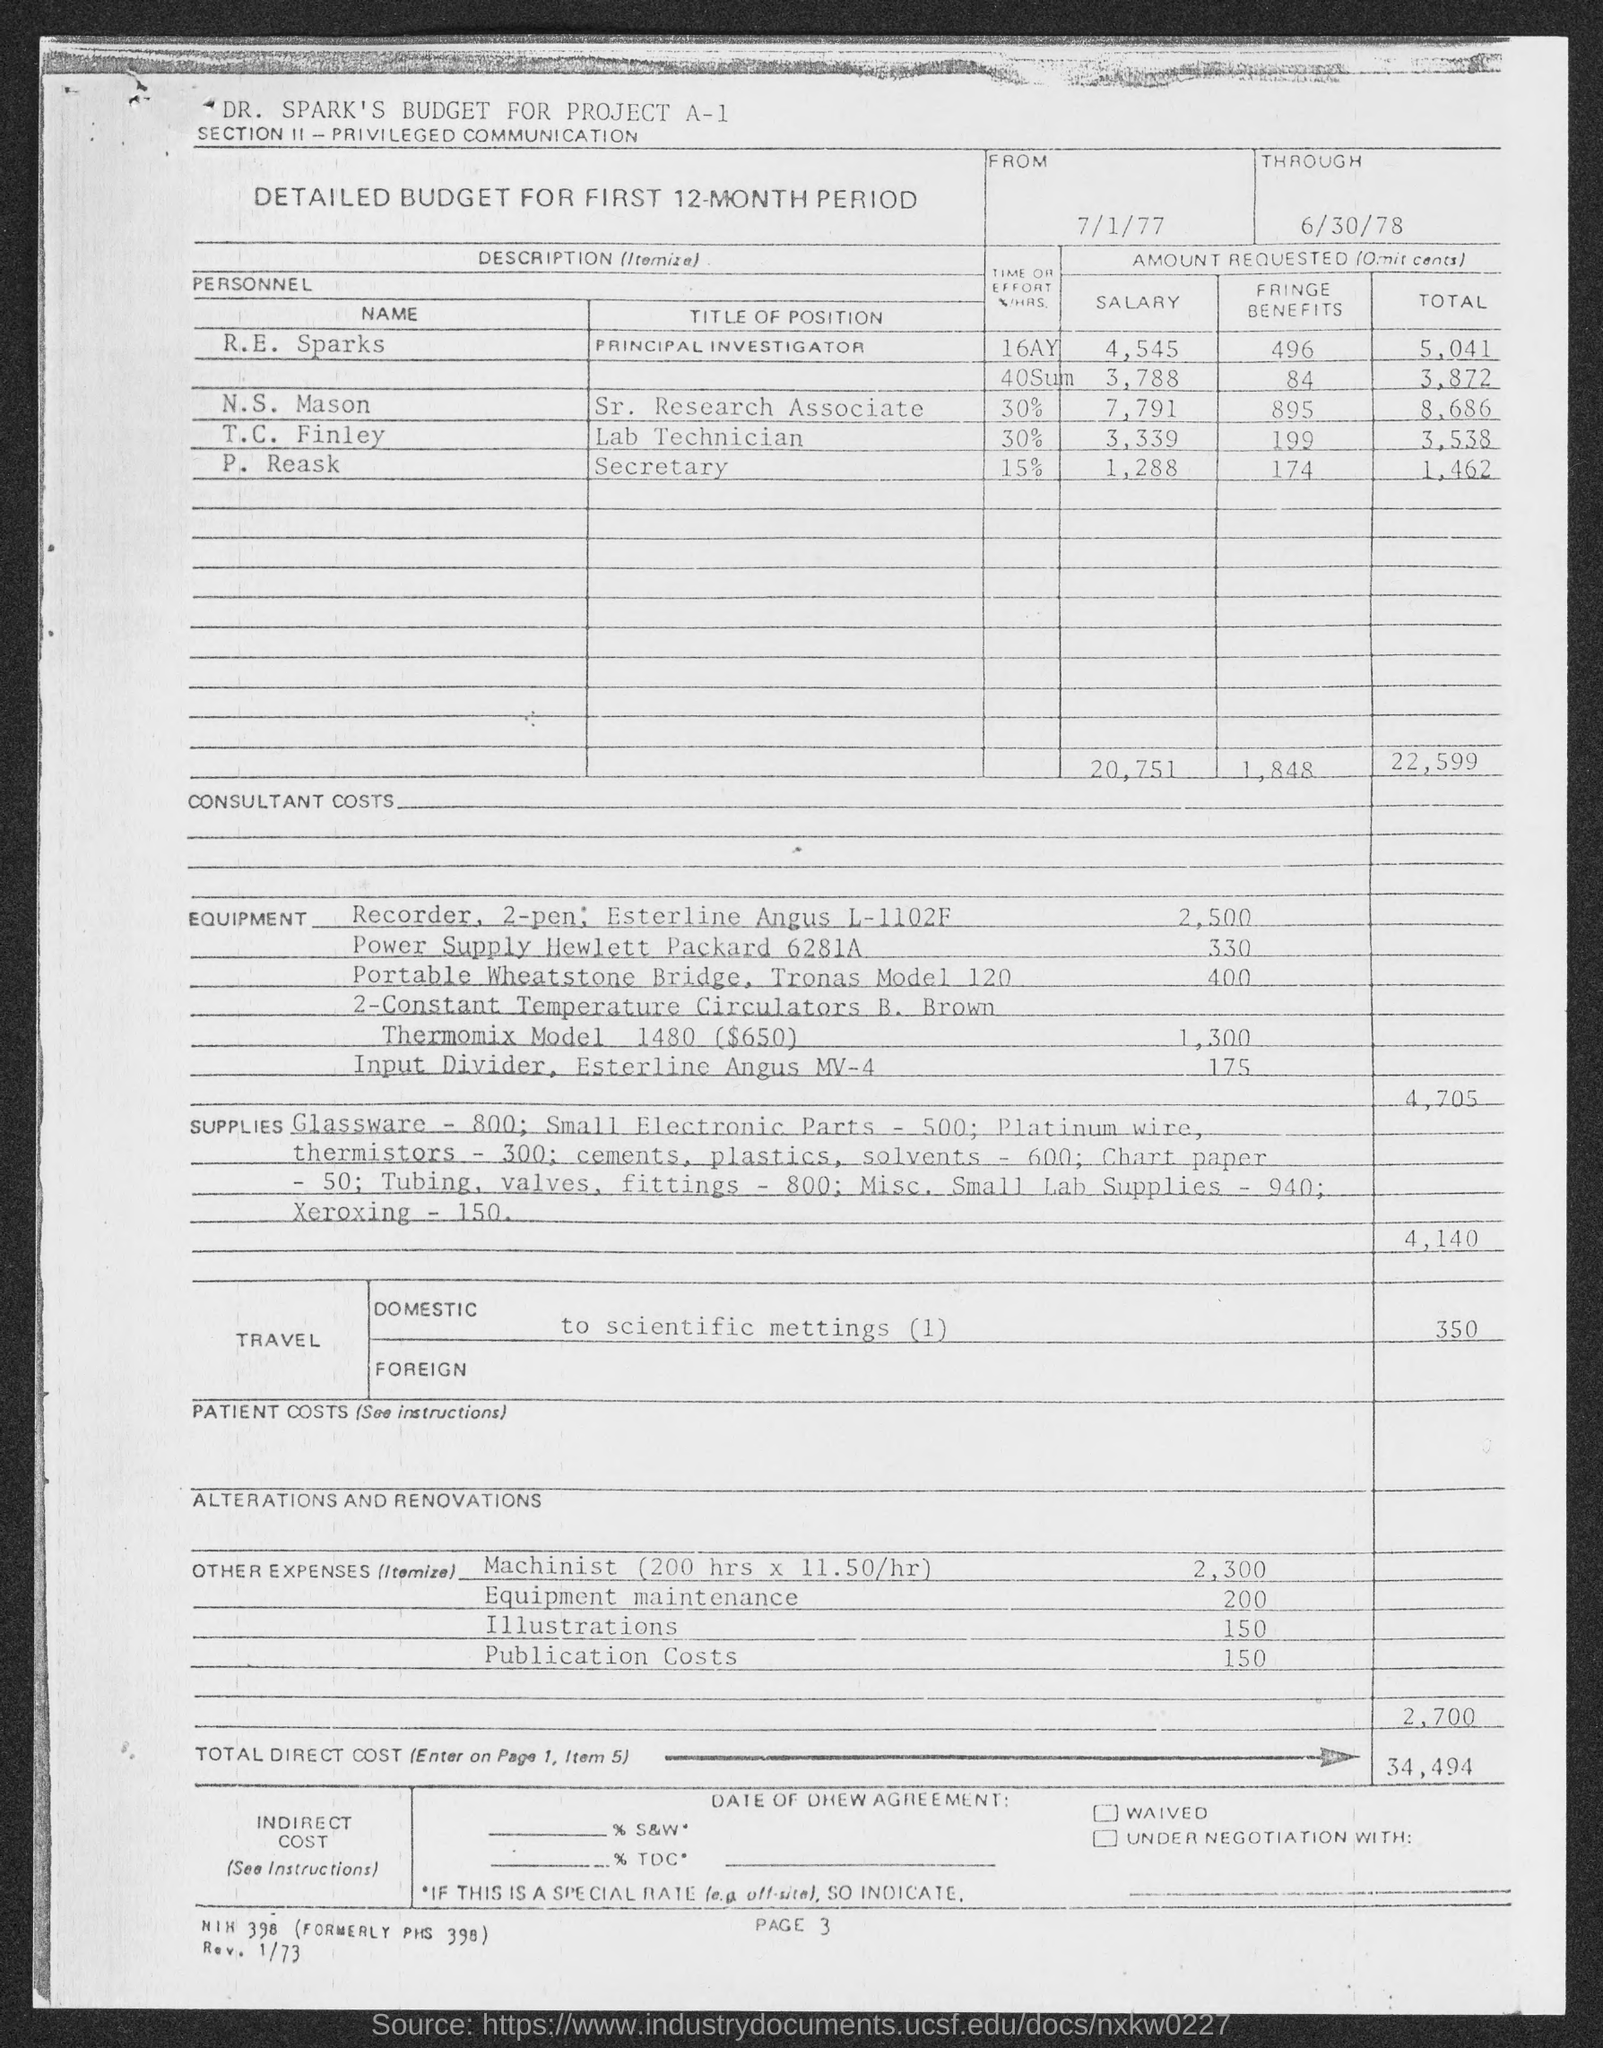Mention a couple of crucial points in this snapshot. The title of the position held by P. Reask, as stated in the document, is Secretary. The total amount requested by T.C. Finley, as stated in the document, is 3,538. R.E. Sparks is the Principal Investigator in the document. The page number mentioned in the document is 3. N.S. Mason devoted 30% of their time and effort to the project. 